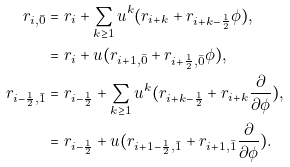<formula> <loc_0><loc_0><loc_500><loc_500>r _ { i , \bar { 0 } } & = r _ { i } + \sum _ { k \geq 1 } { u ^ { k } } ( { r _ { i + k } + r _ { i + k - \frac { 1 } { 2 } } \phi } ) , & & \\ & = r _ { i } + u ( r _ { i + 1 , \bar { 0 } } + r _ { i + \frac { 1 } { 2 } , \bar { 0 } } \phi ) , \\ r _ { i - \frac { 1 } { 2 } , \bar { 1 } } & = r _ { i - \frac { 1 } { 2 } } + \sum _ { k \geq 1 } { u ^ { k } } ( r _ { i + k - \frac { 1 } { 2 } } + r _ { i + k } \frac { \partial } { \partial \phi } ) , & & \quad \\ & = r _ { i - \frac { 1 } { 2 } } + u ( r _ { i + 1 - \frac { 1 } { 2 } , \bar { 1 } } + r _ { i + 1 , \bar { 1 } } \frac { \partial } { \partial \phi } ) .</formula> 